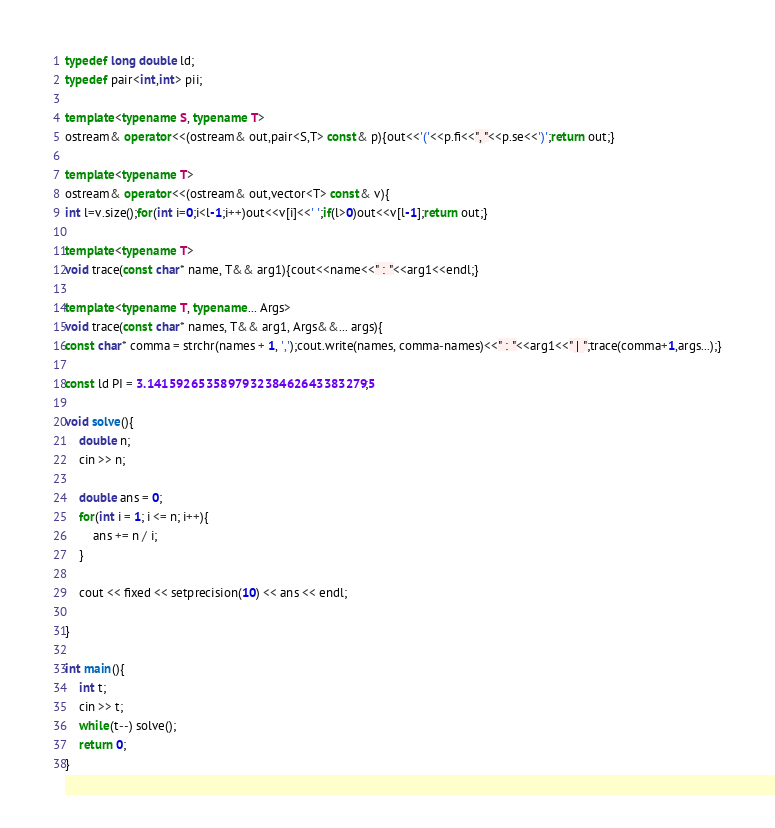Convert code to text. <code><loc_0><loc_0><loc_500><loc_500><_C++_>typedef long double ld;
typedef pair<int,int> pii;

template<typename S, typename T> 
ostream& operator<<(ostream& out,pair<S,T> const& p){out<<'('<<p.fi<<", "<<p.se<<')';return out;}

template<typename T>
ostream& operator<<(ostream& out,vector<T> const& v){
int l=v.size();for(int i=0;i<l-1;i++)out<<v[i]<<' ';if(l>0)out<<v[l-1];return out;}

template<typename T>
void trace(const char* name, T&& arg1){cout<<name<<" : "<<arg1<<endl;}

template<typename T, typename... Args>
void trace(const char* names, T&& arg1, Args&&... args){
const char* comma = strchr(names + 1, ',');cout.write(names, comma-names)<<" : "<<arg1<<" | ";trace(comma+1,args...);}

const ld PI = 3.1415926535897932384626433832795;

void solve(){
	double n;
	cin >> n;
	
	double ans = 0;
	for(int i = 1; i <= n; i++){
		ans += n / i;
	}
	
	cout << fixed << setprecision(10) << ans << endl;
	
}

int main(){
	int t;
	cin >> t;
	while(t--) solve();
	return 0;
}
</code> 